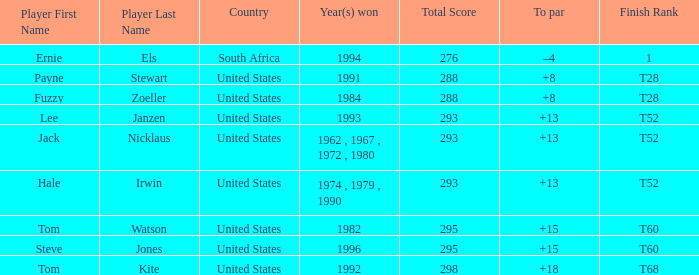What is the average total of player hale irwin, who had a t52 finish? 293.0. 